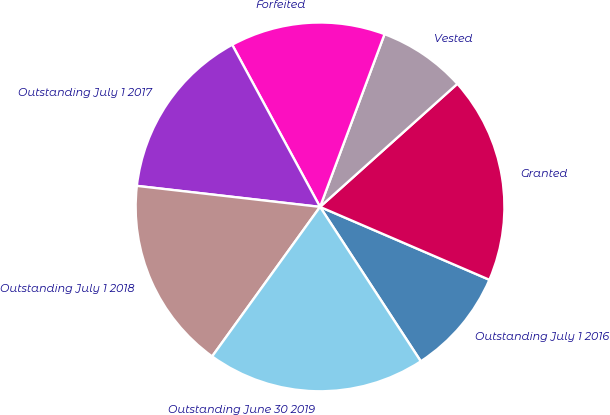Convert chart. <chart><loc_0><loc_0><loc_500><loc_500><pie_chart><fcel>Outstanding July 1 2016<fcel>Granted<fcel>Vested<fcel>Forfeited<fcel>Outstanding July 1 2017<fcel>Outstanding July 1 2018<fcel>Outstanding June 30 2019<nl><fcel>9.33%<fcel>18.1%<fcel>7.68%<fcel>13.59%<fcel>15.28%<fcel>16.87%<fcel>19.15%<nl></chart> 